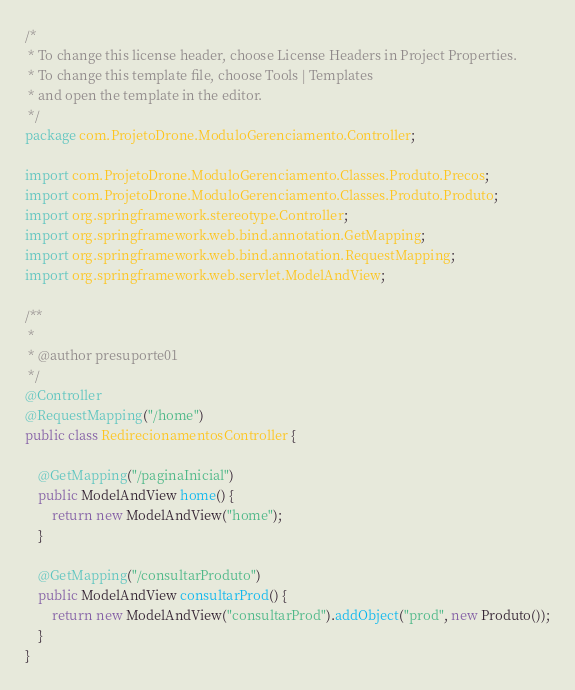Convert code to text. <code><loc_0><loc_0><loc_500><loc_500><_Java_>/*
 * To change this license header, choose License Headers in Project Properties.
 * To change this template file, choose Tools | Templates
 * and open the template in the editor.
 */
package com.ProjetoDrone.ModuloGerenciamento.Controller;

import com.ProjetoDrone.ModuloGerenciamento.Classes.Produto.Precos;
import com.ProjetoDrone.ModuloGerenciamento.Classes.Produto.Produto;
import org.springframework.stereotype.Controller;
import org.springframework.web.bind.annotation.GetMapping;
import org.springframework.web.bind.annotation.RequestMapping;
import org.springframework.web.servlet.ModelAndView;

/**
 *
 * @author presuporte01
 */
@Controller
@RequestMapping("/home")
public class RedirecionamentosController {

    @GetMapping("/paginaInicial")
    public ModelAndView home() {
        return new ModelAndView("home");
    }

    @GetMapping("/consultarProduto")
    public ModelAndView consultarProd() {
        return new ModelAndView("consultarProd").addObject("prod", new Produto());
    }
}
</code> 